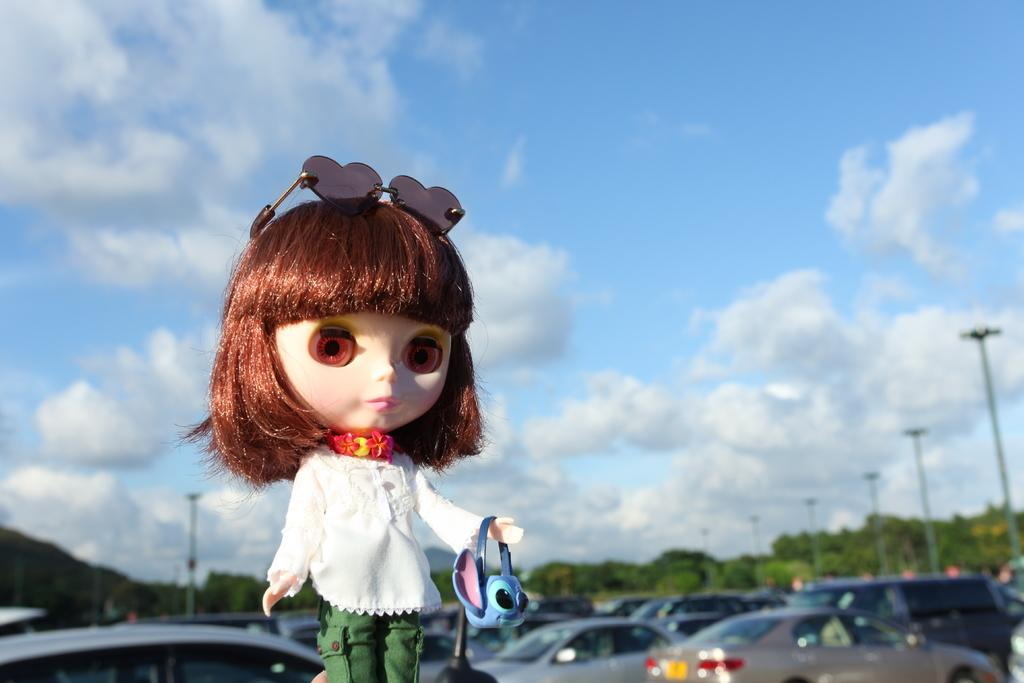What object can be seen in the image? There is a toy in the image. What can be seen in the background of the image? There are vehicles, trees, poles, and the sky visible in the background of the image. What is the condition of the sky in the image? Clouds are present in the sky in the image. What type of business is being conducted in the image? There is no indication of any business being conducted in the image; it primarily features a toy and background elements. Can you tell me how many zebras are present in the image? There are no zebras present in the image. 